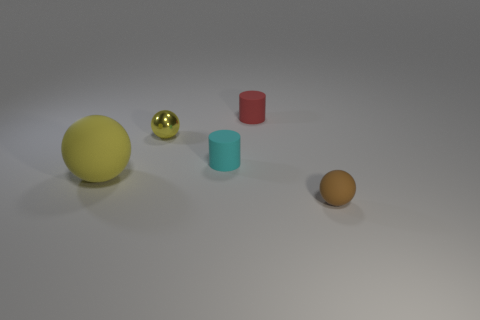There is a yellow object that is the same size as the cyan matte cylinder; what is its material?
Keep it short and to the point. Metal. Is the shape of the thing that is on the left side of the tiny yellow shiny object the same as  the cyan matte thing?
Your answer should be compact. No. Is the large sphere the same color as the metallic object?
Keep it short and to the point. Yes. How many things are balls left of the cyan cylinder or large spheres?
Make the answer very short. 2. The yellow thing that is the same size as the cyan rubber cylinder is what shape?
Give a very brief answer. Sphere. There is a rubber sphere that is behind the small brown rubber sphere; does it have the same size as the matte object that is behind the small yellow metal object?
Ensure brevity in your answer.  No. The small sphere that is made of the same material as the big yellow object is what color?
Your response must be concise. Brown. Does the cylinder that is left of the red matte thing have the same material as the sphere that is to the right of the red thing?
Your answer should be compact. Yes. Are there any matte objects of the same size as the cyan matte cylinder?
Your answer should be compact. Yes. What is the size of the matte thing that is in front of the rubber ball behind the small brown matte object?
Make the answer very short. Small. 